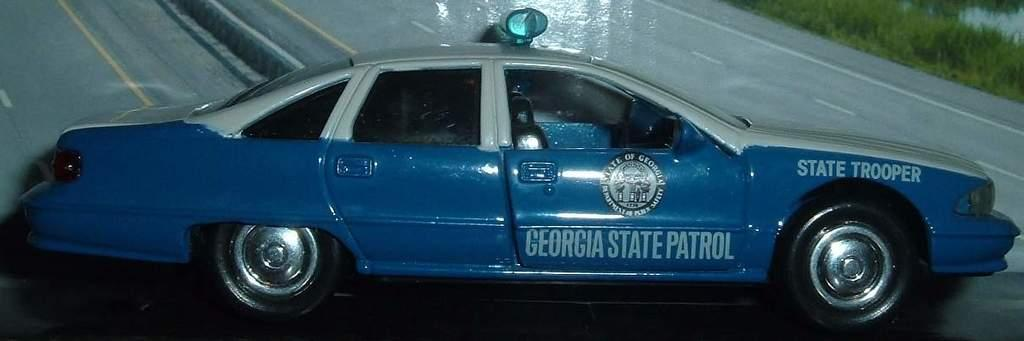What is the main subject of the image? The main subject of the image is a car. What is the car sitting on in the image? The car is on a black surface. What can be seen in the background of the image? There is a road and grass visible in the background of the image. What type of music is being played by the car's team in the image? There is no music or team present in the image; it features a car on a black surface with a road and grass in the background. How many cherries are visible on the car in the image? There are no cherries present in the image; it features a car on a black surface with a road and grass in the background. 